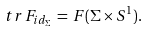Convert formula to latex. <formula><loc_0><loc_0><loc_500><loc_500>t r \, F _ { i d _ { \Sigma } } \, = \, F ( \Sigma \times S ^ { 1 } ) .</formula> 